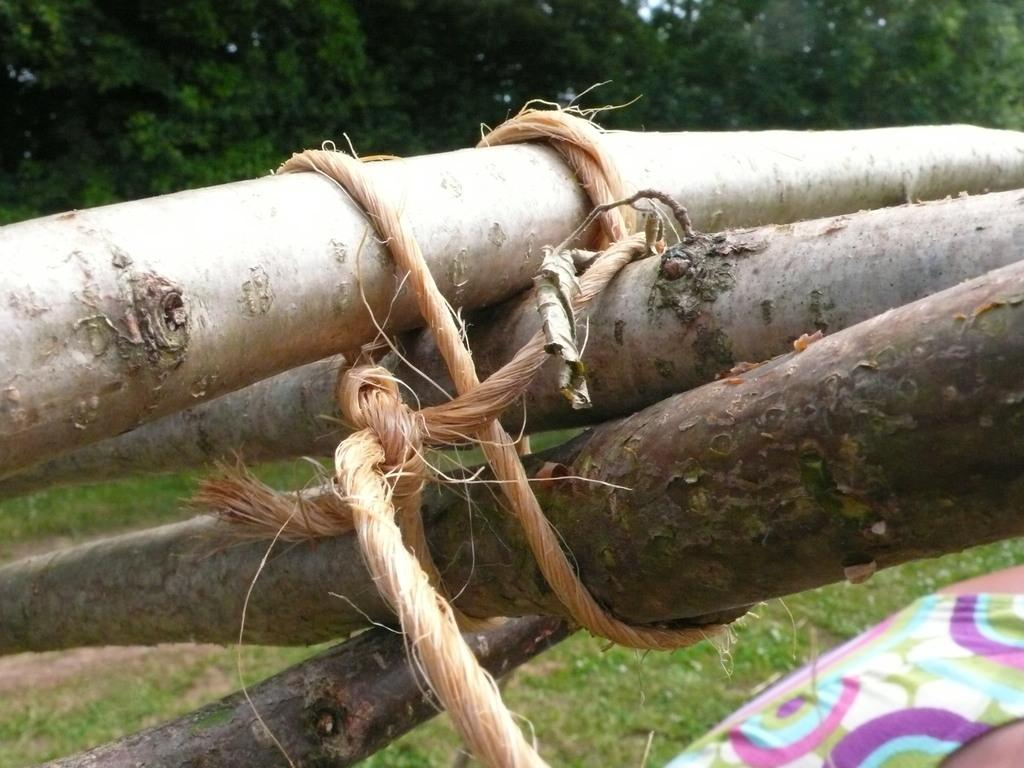What objects are tied with coir rope in the image? There are wooden sticks tied with coir rope in the image. Who is present in the image? There is a person in the image. What type of vegetation is visible in the image? Grass is present in the image. What can be seen in the background of the image? There are trees in the background of the image. What action is the person performing in the middle of the image? There is no specific action being performed by the person in the image, and the image does not have a "middle" as it is a still photograph. 